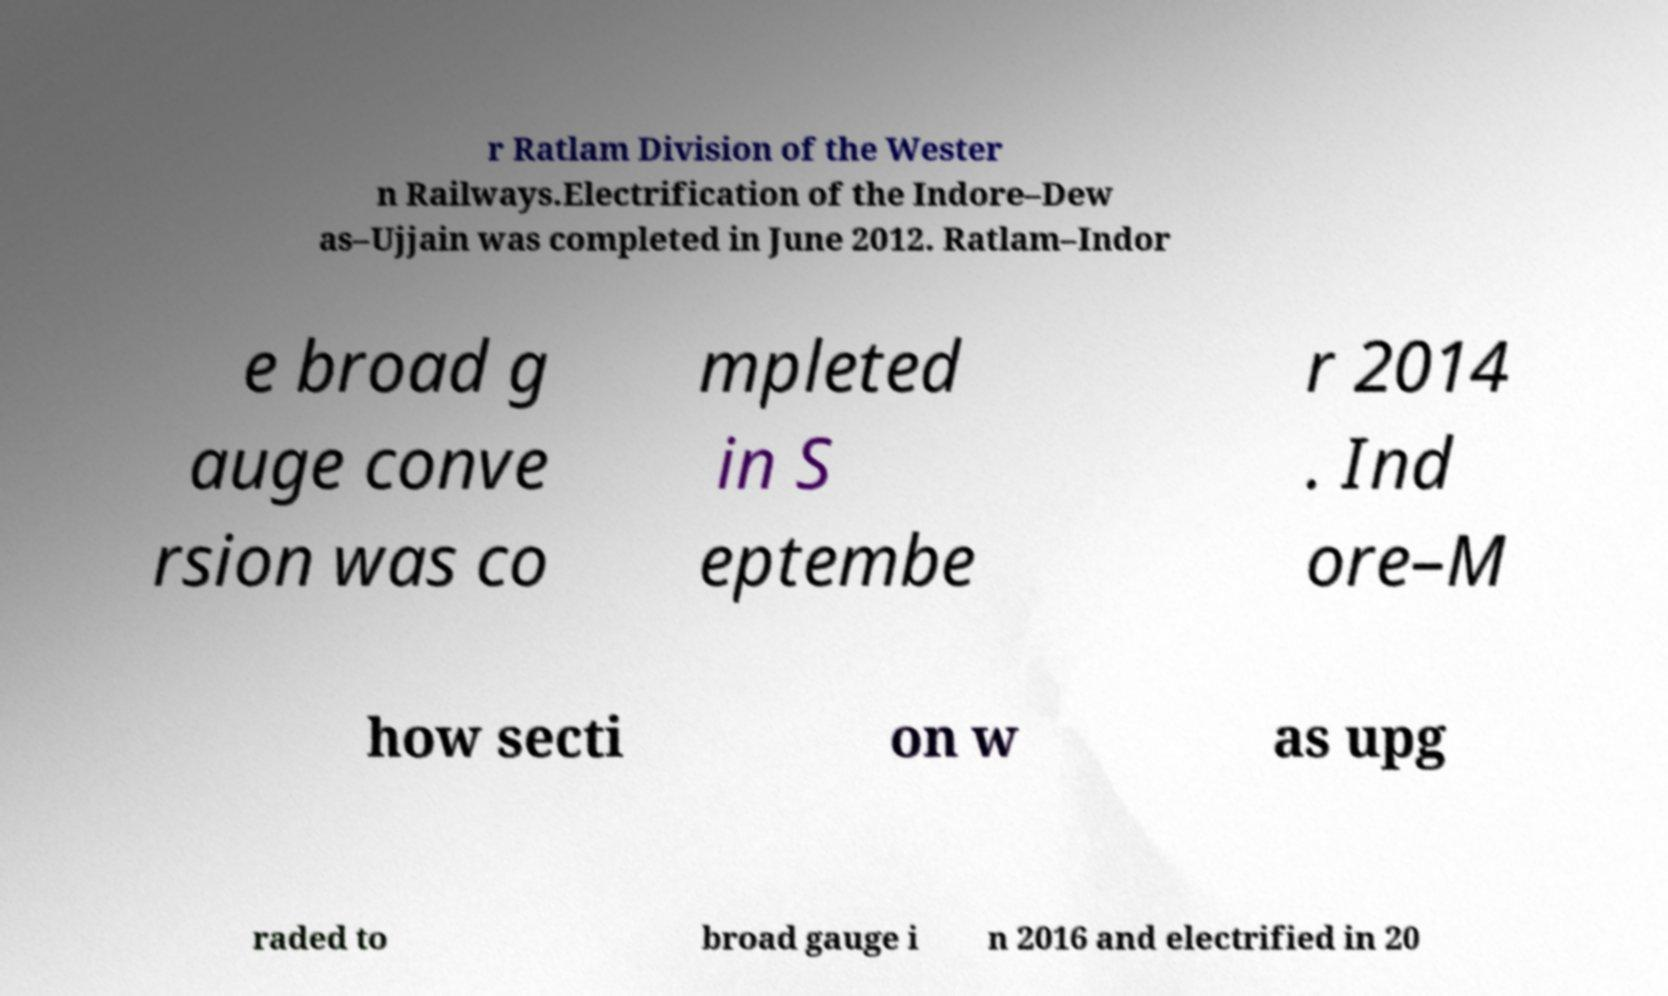Can you accurately transcribe the text from the provided image for me? r Ratlam Division of the Wester n Railways.Electrification of the Indore–Dew as–Ujjain was completed in June 2012. Ratlam–Indor e broad g auge conve rsion was co mpleted in S eptembe r 2014 . Ind ore–M how secti on w as upg raded to broad gauge i n 2016 and electrified in 20 